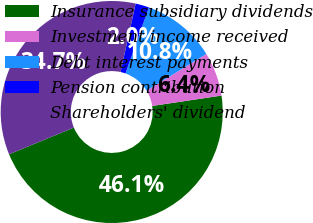<chart> <loc_0><loc_0><loc_500><loc_500><pie_chart><fcel>Insurance subsidiary dividends<fcel>Investment income received<fcel>Debt interest payments<fcel>Pension contribution<fcel>Shareholders' dividend<nl><fcel>46.14%<fcel>6.39%<fcel>10.81%<fcel>1.98%<fcel>34.67%<nl></chart> 